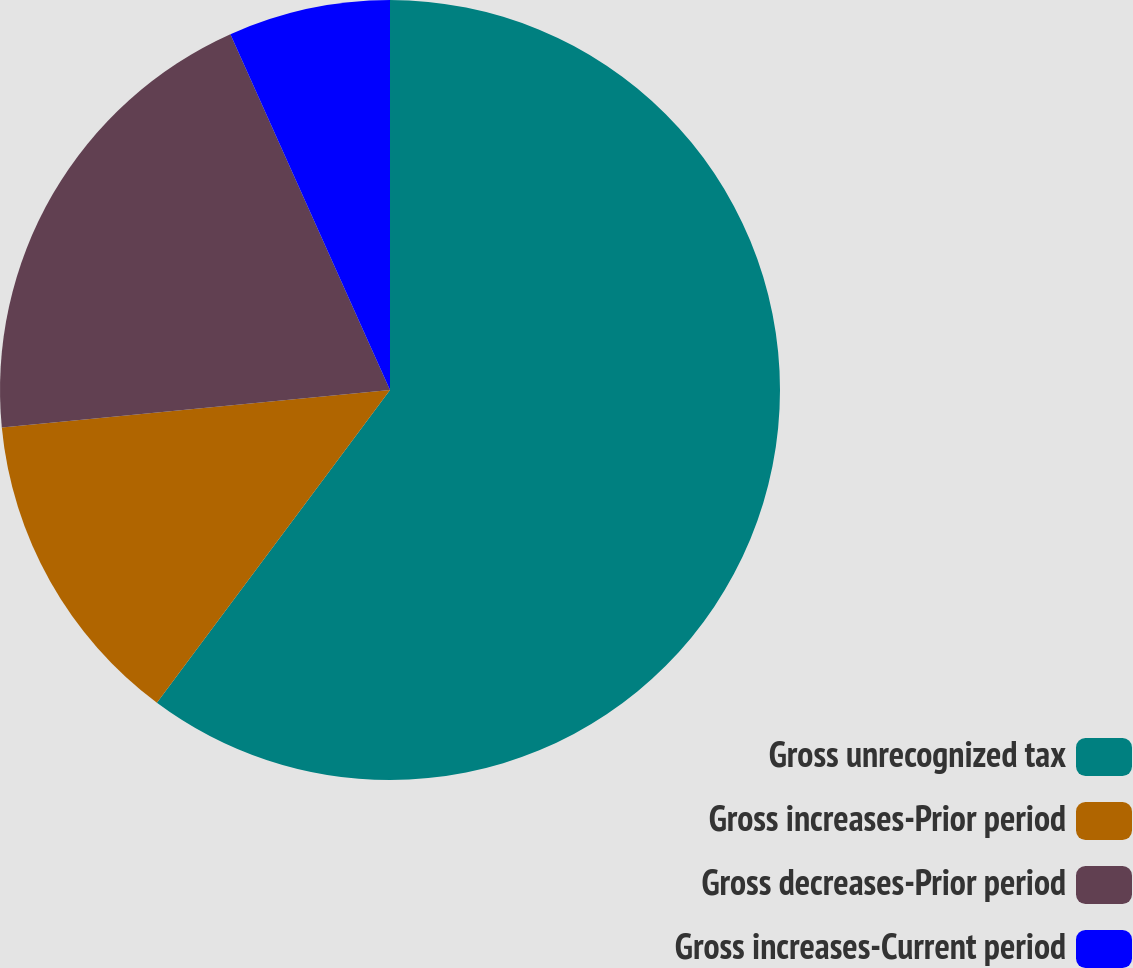<chart> <loc_0><loc_0><loc_500><loc_500><pie_chart><fcel>Gross unrecognized tax<fcel>Gross increases-Prior period<fcel>Gross decreases-Prior period<fcel>Gross increases-Current period<nl><fcel>60.19%<fcel>13.27%<fcel>19.82%<fcel>6.71%<nl></chart> 